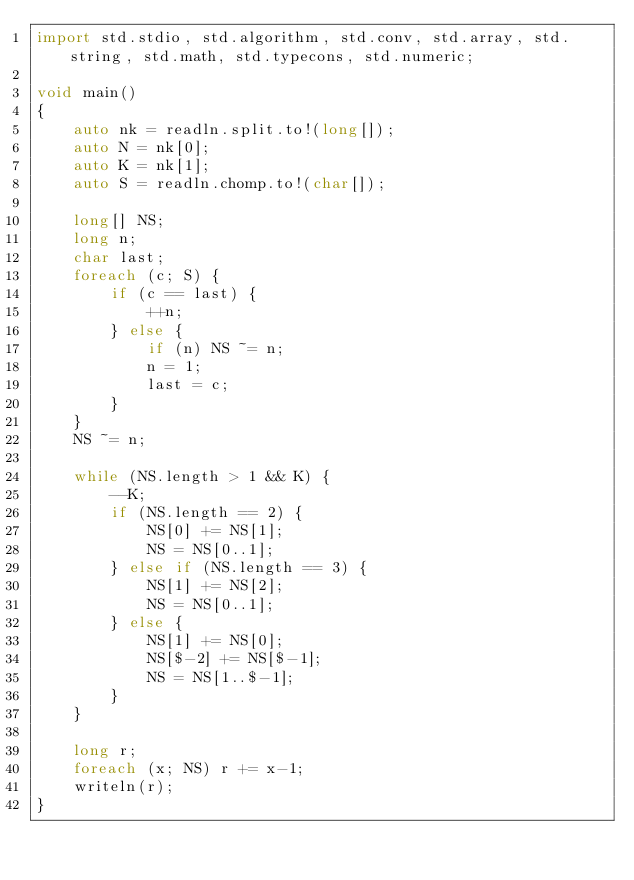<code> <loc_0><loc_0><loc_500><loc_500><_D_>import std.stdio, std.algorithm, std.conv, std.array, std.string, std.math, std.typecons, std.numeric;

void main()
{
    auto nk = readln.split.to!(long[]);
    auto N = nk[0];
    auto K = nk[1];
    auto S = readln.chomp.to!(char[]);

    long[] NS;
    long n;
    char last;
    foreach (c; S) {
        if (c == last) {
            ++n;
        } else {
            if (n) NS ~= n;
            n = 1;
            last = c;
        }
    }
    NS ~= n;
    
    while (NS.length > 1 && K) {
        --K;
        if (NS.length == 2) {
            NS[0] += NS[1];
            NS = NS[0..1];
        } else if (NS.length == 3) {
            NS[1] += NS[2];
            NS = NS[0..1];
        } else {
            NS[1] += NS[0];
            NS[$-2] += NS[$-1];
            NS = NS[1..$-1];
        }
    }

    long r;
    foreach (x; NS) r += x-1;
    writeln(r);
}</code> 